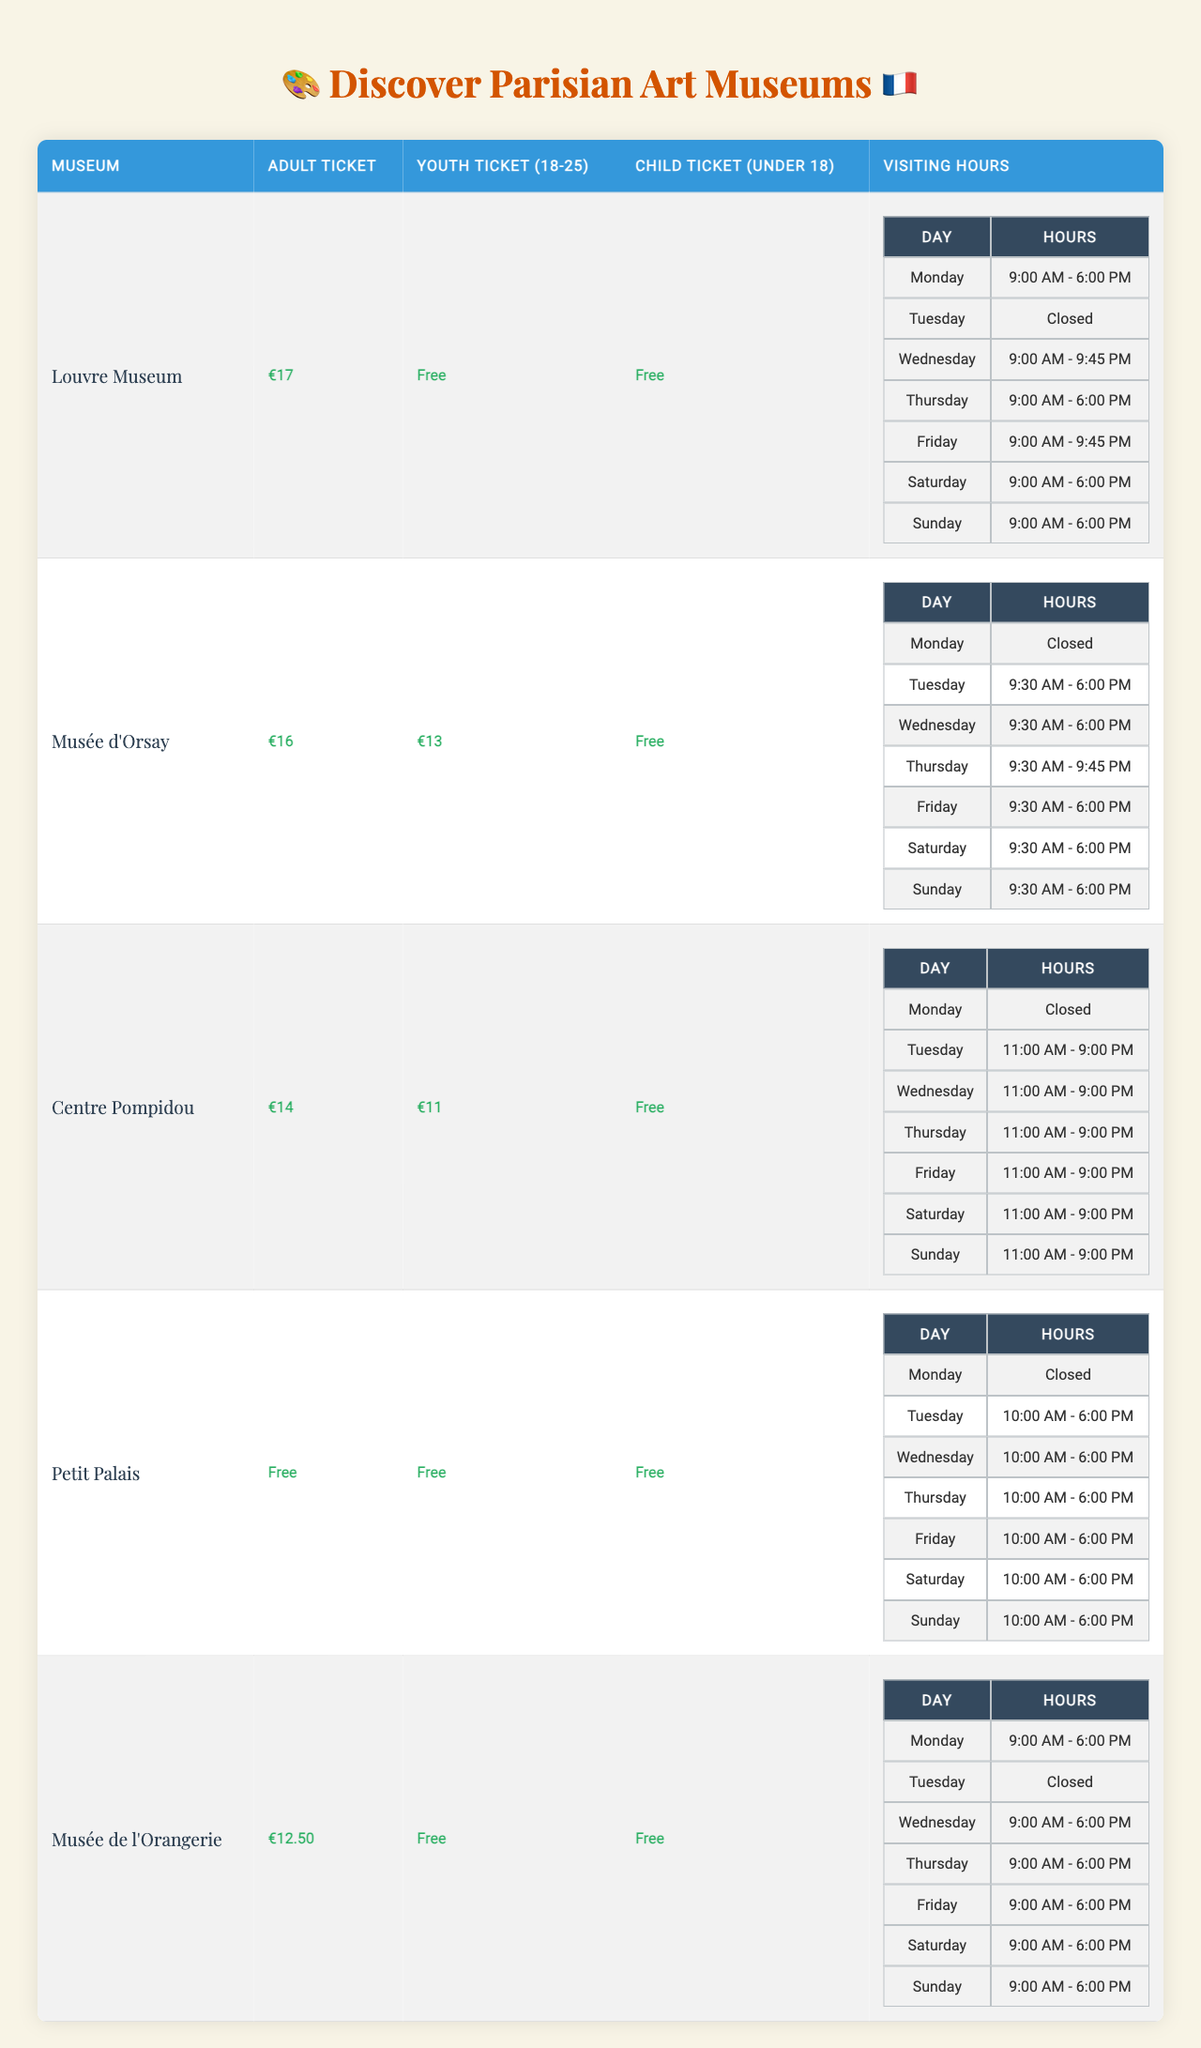What is the ticket price for adults at the Louvre Museum? The table shows that the adult ticket price at the Louvre Museum is €17.
Answer: €17 What are the visiting hours for the Musée d'Orsay on Thursday? According to the table, the Musée d'Orsay opens at 9:30 AM and closes at 9:45 PM on Thursdays.
Answer: 9:30 AM - 9:45 PM Is the child ticket free at the Centre Pompidou? The table indicates that the child ticket (Under 18) is free at the Centre Pompidou.
Answer: Yes How much do youth tickets cost at the Petit Palais? The Petit Palais offers free entry for youth tickets (18-25), as stated in the table.
Answer: Free On which day is the Louvre Museum closed? The table indicates that the Louvre Museum is closed on Tuesdays.
Answer: Tuesday What is the difference in price between an adult ticket at the Musée d'Orsay and the Louvre Museum? The adult ticket at the Musée d'Orsay is €16 and at the Louvre Museum is €17. The difference is €17 - €16 = €1.
Answer: €1 If a youth and a child visit the Musée de l'Orangerie, what would the total cost be? The youth ticket is free, and the child ticket is also free, so the total cost is €0 + €0 = €0.
Answer: €0 How late does the Centre Pompidou stay open on Wednesday? The Centre Pompidou is open until 9:00 PM on Wednesdays, according to the table.
Answer: 9:00 PM Which museum has the longest visiting hours on Friday? The Louvre Museum and the Centre Pompidou both have visiting hours until 9:45 PM on Fridays, which is longer than others.
Answer: Louvre Museum and Centre Pompidou What is the average price of an adult ticket across all the museums listed? The adult ticket prices are €17 (Louvre) + €16 (Musée d'Orsay) + €14 (Centre Pompidou) + €0 (Petit Palais) + €12.50 (Musée de l'Orangerie) = €59.5. There are 5 museums, so the average is €59.5/5 = €11.90.
Answer: €11.90 On which days can you visit the Petit Palais? The table shows that the Petit Palais is open from Tuesday to Sunday, and it is closed on Monday.
Answer: Tuesday to Sunday 